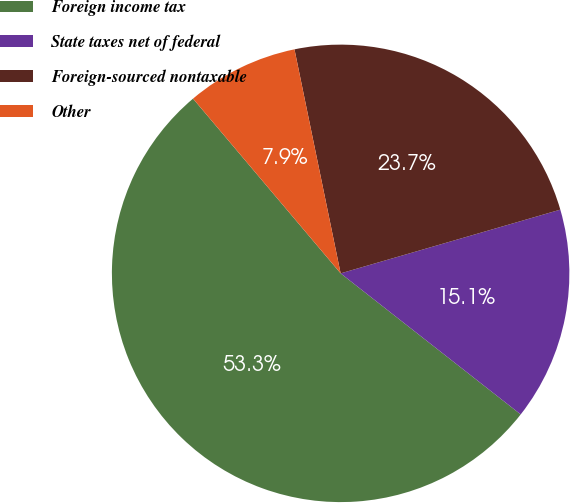Convert chart. <chart><loc_0><loc_0><loc_500><loc_500><pie_chart><fcel>Foreign income tax<fcel>State taxes net of federal<fcel>Foreign-sourced nontaxable<fcel>Other<nl><fcel>53.26%<fcel>15.07%<fcel>23.74%<fcel>7.93%<nl></chart> 